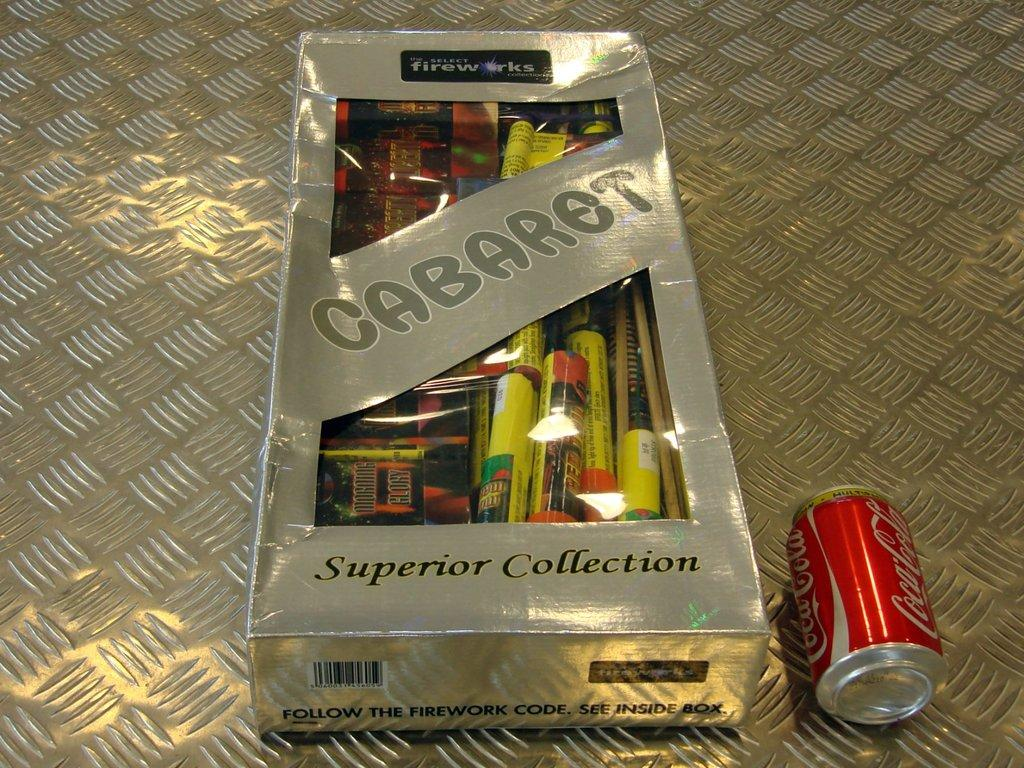<image>
Provide a brief description of the given image. A large box of Cabaret fireworks sits next to a Coke can. 